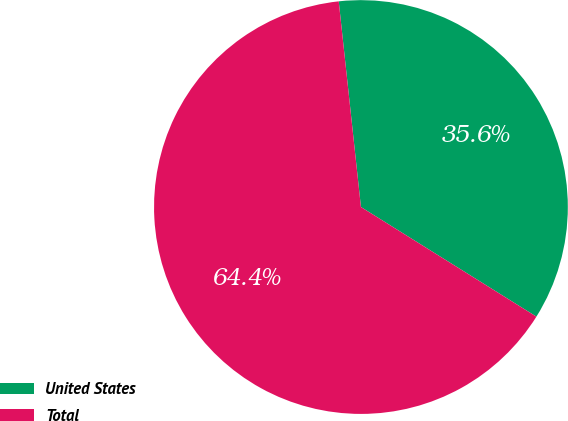Convert chart to OTSL. <chart><loc_0><loc_0><loc_500><loc_500><pie_chart><fcel>United States<fcel>Total<nl><fcel>35.6%<fcel>64.4%<nl></chart> 